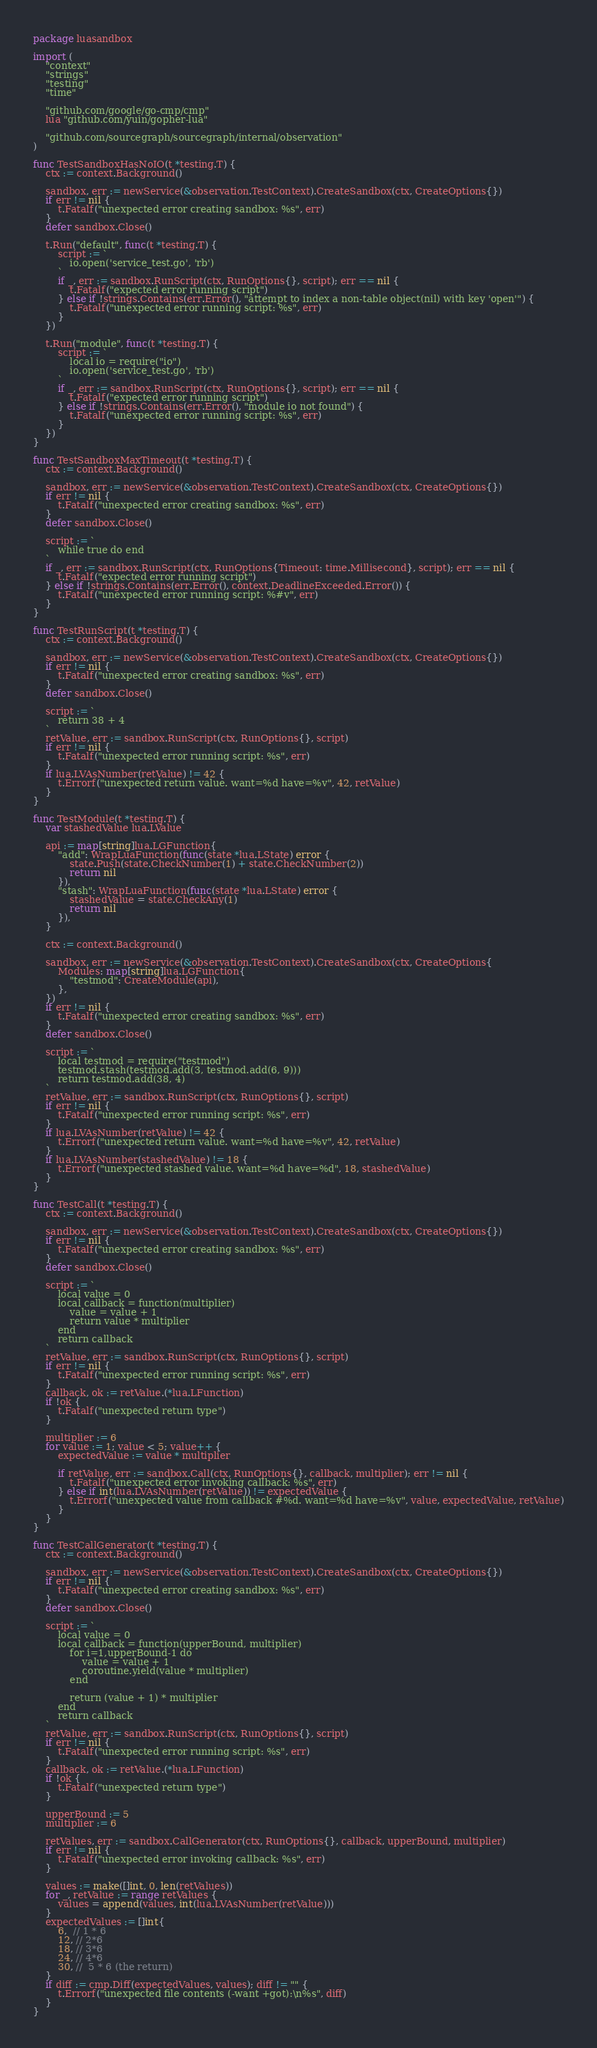<code> <loc_0><loc_0><loc_500><loc_500><_Go_>package luasandbox

import (
	"context"
	"strings"
	"testing"
	"time"

	"github.com/google/go-cmp/cmp"
	lua "github.com/yuin/gopher-lua"

	"github.com/sourcegraph/sourcegraph/internal/observation"
)

func TestSandboxHasNoIO(t *testing.T) {
	ctx := context.Background()

	sandbox, err := newService(&observation.TestContext).CreateSandbox(ctx, CreateOptions{})
	if err != nil {
		t.Fatalf("unexpected error creating sandbox: %s", err)
	}
	defer sandbox.Close()

	t.Run("default", func(t *testing.T) {
		script := `
			io.open('service_test.go', 'rb')
		`
		if _, err := sandbox.RunScript(ctx, RunOptions{}, script); err == nil {
			t.Fatalf("expected error running script")
		} else if !strings.Contains(err.Error(), "attempt to index a non-table object(nil) with key 'open'") {
			t.Fatalf("unexpected error running script: %s", err)
		}
	})

	t.Run("module", func(t *testing.T) {
		script := `
			local io = require("io")
			io.open('service_test.go', 'rb')
		`
		if _, err := sandbox.RunScript(ctx, RunOptions{}, script); err == nil {
			t.Fatalf("expected error running script")
		} else if !strings.Contains(err.Error(), "module io not found") {
			t.Fatalf("unexpected error running script: %s", err)
		}
	})
}

func TestSandboxMaxTimeout(t *testing.T) {
	ctx := context.Background()

	sandbox, err := newService(&observation.TestContext).CreateSandbox(ctx, CreateOptions{})
	if err != nil {
		t.Fatalf("unexpected error creating sandbox: %s", err)
	}
	defer sandbox.Close()

	script := `
		while true do end
	`
	if _, err := sandbox.RunScript(ctx, RunOptions{Timeout: time.Millisecond}, script); err == nil {
		t.Fatalf("expected error running script")
	} else if !strings.Contains(err.Error(), context.DeadlineExceeded.Error()) {
		t.Fatalf("unexpected error running script: %#v", err)
	}
}

func TestRunScript(t *testing.T) {
	ctx := context.Background()

	sandbox, err := newService(&observation.TestContext).CreateSandbox(ctx, CreateOptions{})
	if err != nil {
		t.Fatalf("unexpected error creating sandbox: %s", err)
	}
	defer sandbox.Close()

	script := `
		return 38 + 4
	`
	retValue, err := sandbox.RunScript(ctx, RunOptions{}, script)
	if err != nil {
		t.Fatalf("unexpected error running script: %s", err)
	}
	if lua.LVAsNumber(retValue) != 42 {
		t.Errorf("unexpected return value. want=%d have=%v", 42, retValue)
	}
}

func TestModule(t *testing.T) {
	var stashedValue lua.LValue

	api := map[string]lua.LGFunction{
		"add": WrapLuaFunction(func(state *lua.LState) error {
			state.Push(state.CheckNumber(1) + state.CheckNumber(2))
			return nil
		}),
		"stash": WrapLuaFunction(func(state *lua.LState) error {
			stashedValue = state.CheckAny(1)
			return nil
		}),
	}

	ctx := context.Background()

	sandbox, err := newService(&observation.TestContext).CreateSandbox(ctx, CreateOptions{
		Modules: map[string]lua.LGFunction{
			"testmod": CreateModule(api),
		},
	})
	if err != nil {
		t.Fatalf("unexpected error creating sandbox: %s", err)
	}
	defer sandbox.Close()

	script := `
		local testmod = require("testmod")
		testmod.stash(testmod.add(3, testmod.add(6, 9)))
		return testmod.add(38, 4)
	`
	retValue, err := sandbox.RunScript(ctx, RunOptions{}, script)
	if err != nil {
		t.Fatalf("unexpected error running script: %s", err)
	}
	if lua.LVAsNumber(retValue) != 42 {
		t.Errorf("unexpected return value. want=%d have=%v", 42, retValue)
	}
	if lua.LVAsNumber(stashedValue) != 18 {
		t.Errorf("unexpected stashed value. want=%d have=%d", 18, stashedValue)
	}
}

func TestCall(t *testing.T) {
	ctx := context.Background()

	sandbox, err := newService(&observation.TestContext).CreateSandbox(ctx, CreateOptions{})
	if err != nil {
		t.Fatalf("unexpected error creating sandbox: %s", err)
	}
	defer sandbox.Close()

	script := `
		local value = 0
		local callback = function(multiplier)
			value = value + 1
			return value * multiplier
		end
		return callback
	`
	retValue, err := sandbox.RunScript(ctx, RunOptions{}, script)
	if err != nil {
		t.Fatalf("unexpected error running script: %s", err)
	}
	callback, ok := retValue.(*lua.LFunction)
	if !ok {
		t.Fatalf("unexpected return type")
	}

	multiplier := 6
	for value := 1; value < 5; value++ {
		expectedValue := value * multiplier

		if retValue, err := sandbox.Call(ctx, RunOptions{}, callback, multiplier); err != nil {
			t.Fatalf("unexpected error invoking callback: %s", err)
		} else if int(lua.LVAsNumber(retValue)) != expectedValue {
			t.Errorf("unexpected value from callback #%d. want=%d have=%v", value, expectedValue, retValue)
		}
	}
}

func TestCallGenerator(t *testing.T) {
	ctx := context.Background()

	sandbox, err := newService(&observation.TestContext).CreateSandbox(ctx, CreateOptions{})
	if err != nil {
		t.Fatalf("unexpected error creating sandbox: %s", err)
	}
	defer sandbox.Close()

	script := `
		local value = 0
		local callback = function(upperBound, multiplier)
			for i=1,upperBound-1 do
				value = value + 1
				coroutine.yield(value * multiplier)
			end

			return (value + 1) * multiplier
		end
		return callback
	`
	retValue, err := sandbox.RunScript(ctx, RunOptions{}, script)
	if err != nil {
		t.Fatalf("unexpected error running script: %s", err)
	}
	callback, ok := retValue.(*lua.LFunction)
	if !ok {
		t.Fatalf("unexpected return type")
	}

	upperBound := 5
	multiplier := 6

	retValues, err := sandbox.CallGenerator(ctx, RunOptions{}, callback, upperBound, multiplier)
	if err != nil {
		t.Fatalf("unexpected error invoking callback: %s", err)
	}

	values := make([]int, 0, len(retValues))
	for _, retValue := range retValues {
		values = append(values, int(lua.LVAsNumber(retValue)))
	}
	expectedValues := []int{
		6,  // 1 * 6
		12, // 2*6
		18, // 3*6
		24, // 4*6
		30, //  5 * 6 (the return)
	}
	if diff := cmp.Diff(expectedValues, values); diff != "" {
		t.Errorf("unexpected file contents (-want +got):\n%s", diff)
	}
}
</code> 